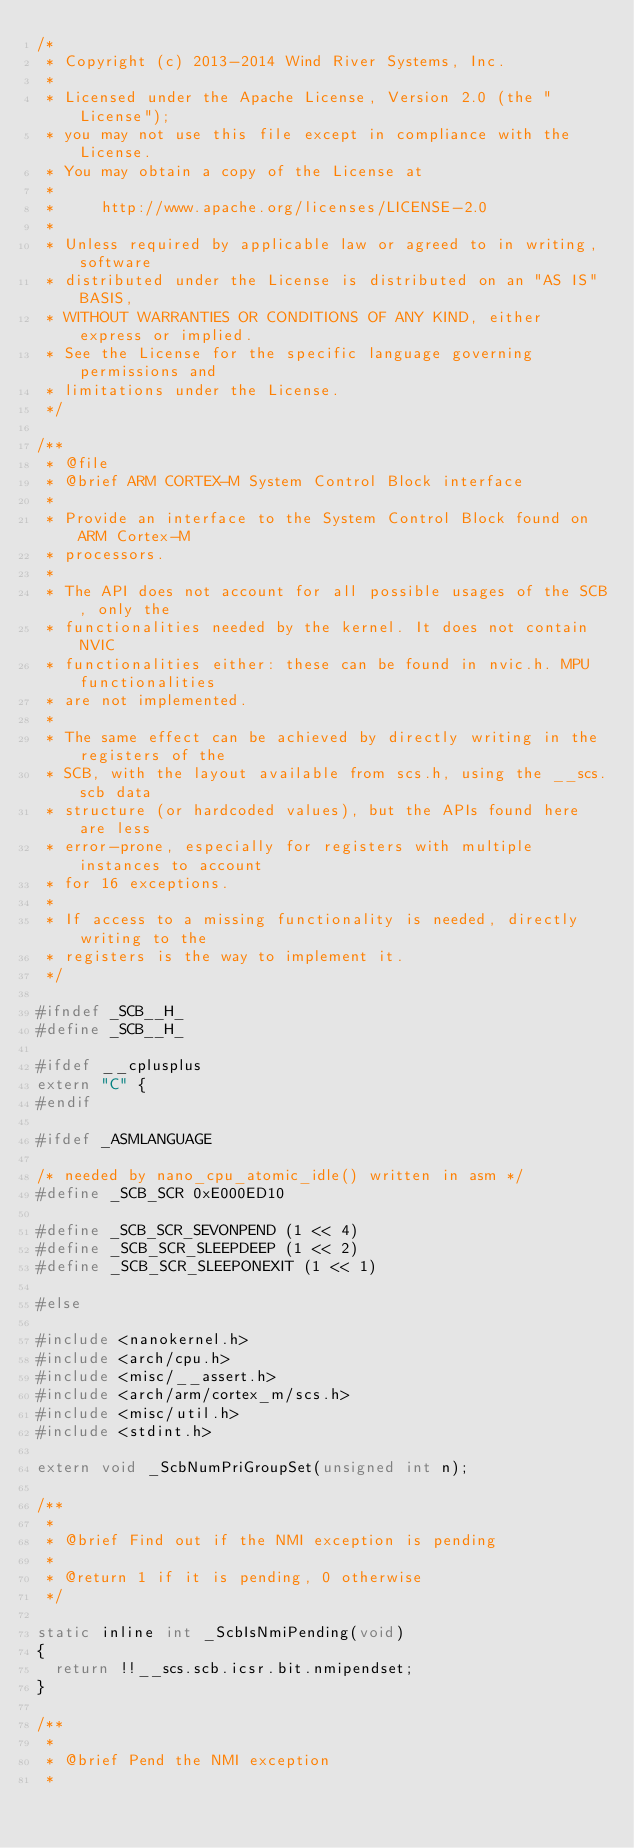Convert code to text. <code><loc_0><loc_0><loc_500><loc_500><_C_>/*
 * Copyright (c) 2013-2014 Wind River Systems, Inc.
 *
 * Licensed under the Apache License, Version 2.0 (the "License");
 * you may not use this file except in compliance with the License.
 * You may obtain a copy of the License at
 *
 *     http://www.apache.org/licenses/LICENSE-2.0
 *
 * Unless required by applicable law or agreed to in writing, software
 * distributed under the License is distributed on an "AS IS" BASIS,
 * WITHOUT WARRANTIES OR CONDITIONS OF ANY KIND, either express or implied.
 * See the License for the specific language governing permissions and
 * limitations under the License.
 */

/**
 * @file
 * @brief ARM CORTEX-M System Control Block interface
 *
 * Provide an interface to the System Control Block found on ARM Cortex-M
 * processors.
 *
 * The API does not account for all possible usages of the SCB, only the
 * functionalities needed by the kernel. It does not contain NVIC
 * functionalities either: these can be found in nvic.h. MPU functionalities
 * are not implemented.
 *
 * The same effect can be achieved by directly writing in the registers of the
 * SCB, with the layout available from scs.h, using the __scs.scb data
 * structure (or hardcoded values), but the APIs found here are less
 * error-prone, especially for registers with multiple instances to account
 * for 16 exceptions.
 *
 * If access to a missing functionality is needed, directly writing to the
 * registers is the way to implement it.
 */

#ifndef _SCB__H_
#define _SCB__H_

#ifdef __cplusplus
extern "C" {
#endif

#ifdef _ASMLANGUAGE

/* needed by nano_cpu_atomic_idle() written in asm */
#define _SCB_SCR 0xE000ED10

#define _SCB_SCR_SEVONPEND (1 << 4)
#define _SCB_SCR_SLEEPDEEP (1 << 2)
#define _SCB_SCR_SLEEPONEXIT (1 << 1)

#else

#include <nanokernel.h>
#include <arch/cpu.h>
#include <misc/__assert.h>
#include <arch/arm/cortex_m/scs.h>
#include <misc/util.h>
#include <stdint.h>

extern void _ScbNumPriGroupSet(unsigned int n);

/**
 *
 * @brief Find out if the NMI exception is pending
 *
 * @return 1 if it is pending, 0 otherwise
 */

static inline int _ScbIsNmiPending(void)
{
	return !!__scs.scb.icsr.bit.nmipendset;
}

/**
 *
 * @brief Pend the NMI exception
 *</code> 